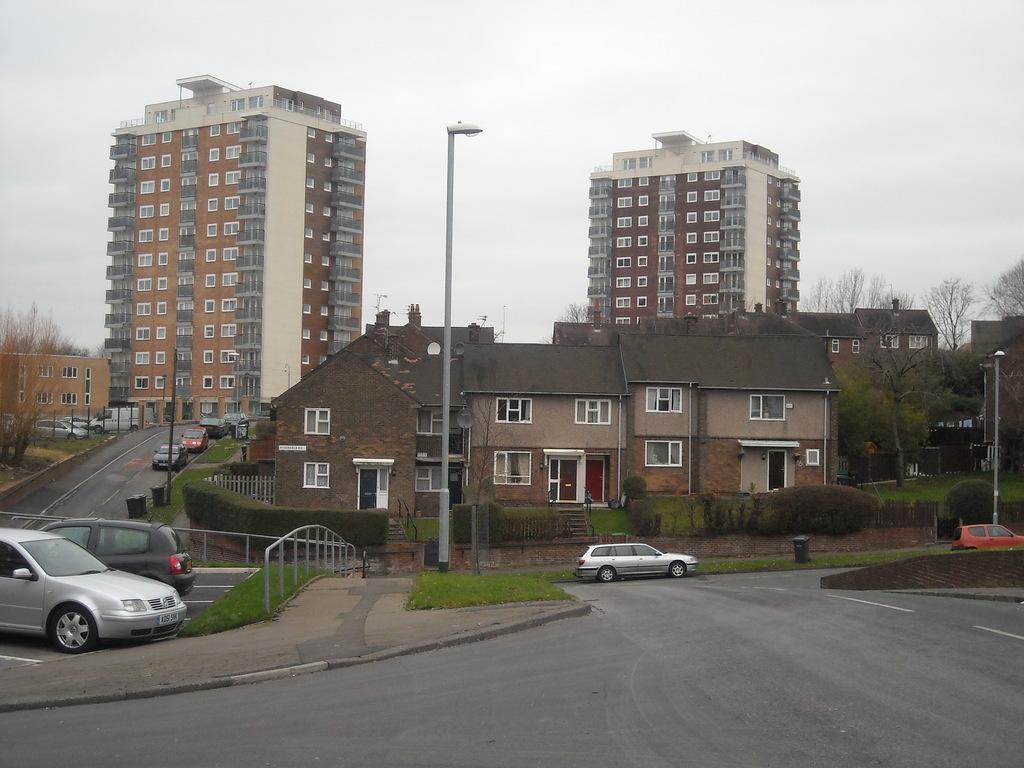How would you summarize this image in a sentence or two? In this image I see the road, fencing, cars, grass, bushes and I see number of buildings and I see the poles and the trees and in the background I see the sky. 